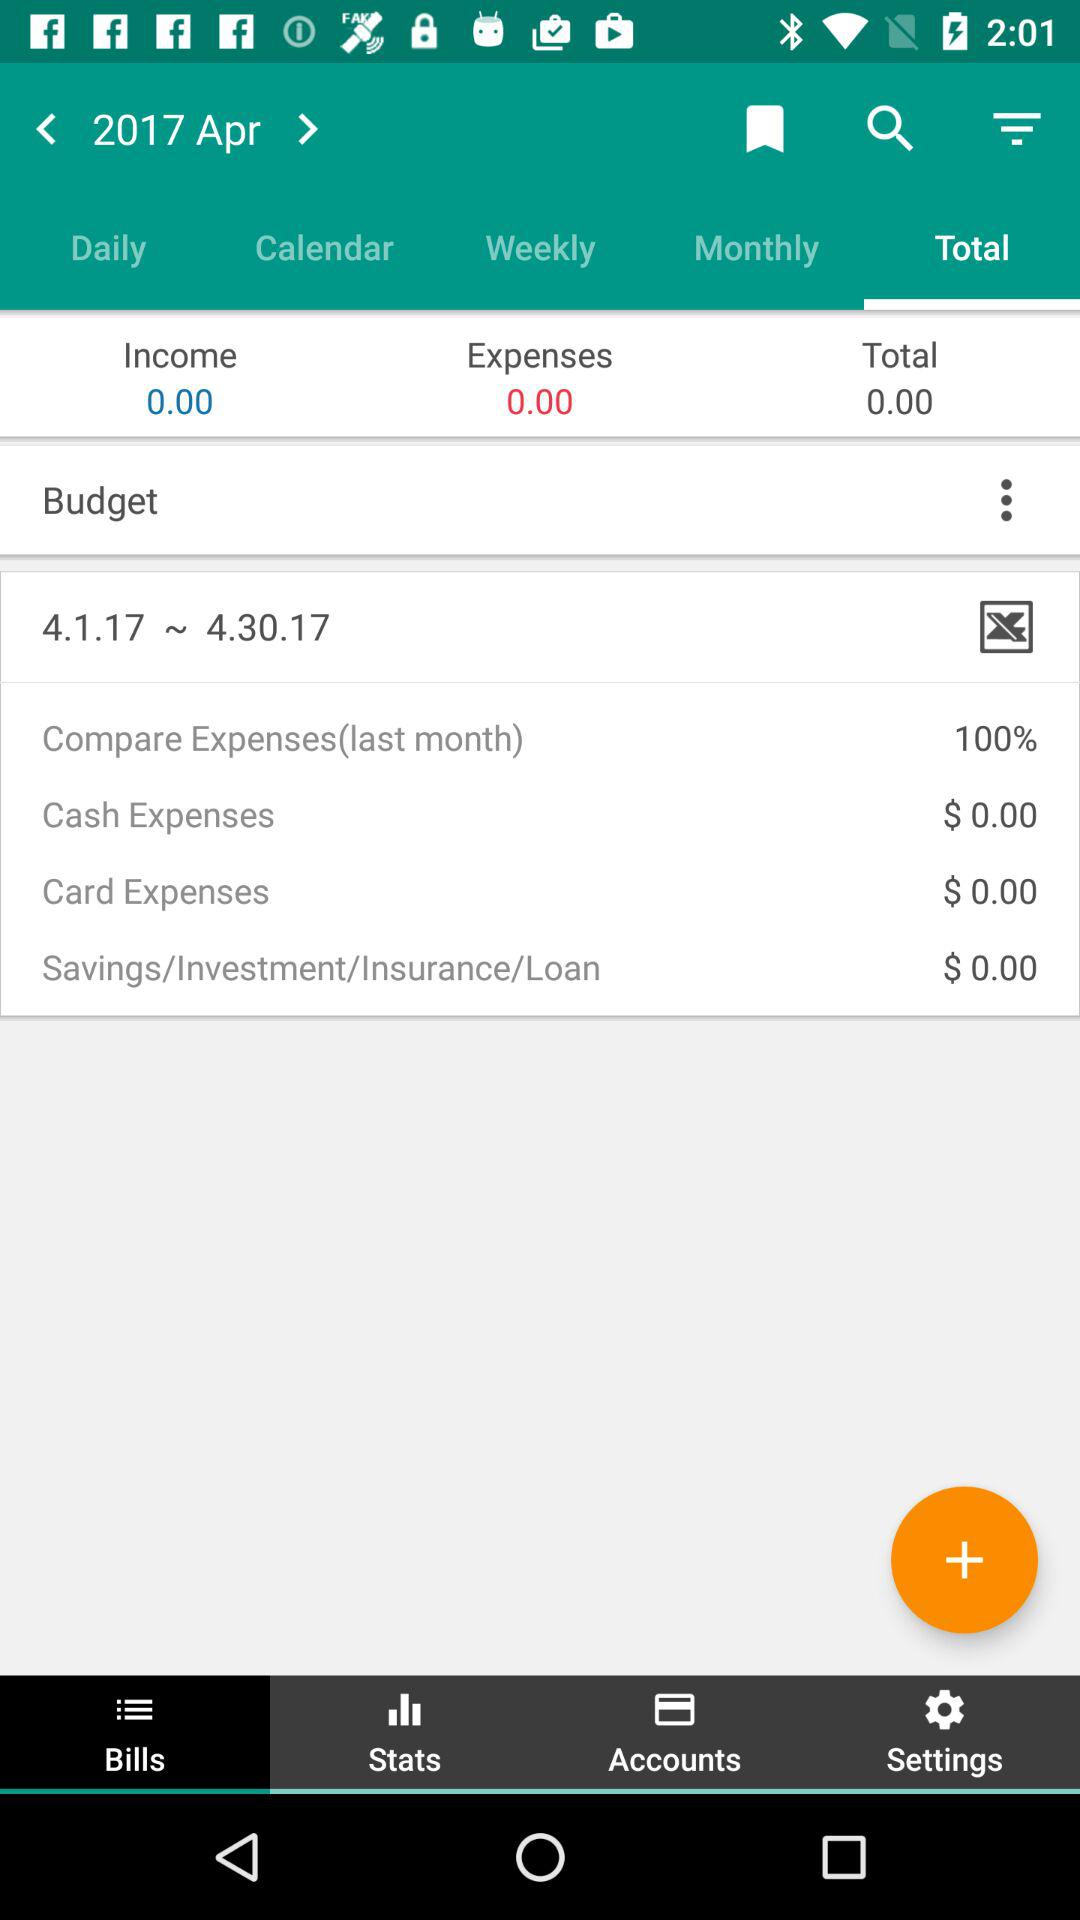What is the percentage mentioned for "Compare Expenses(last month)"? The percentage mentioned for "Compare Expenses(last month)" is 100. 